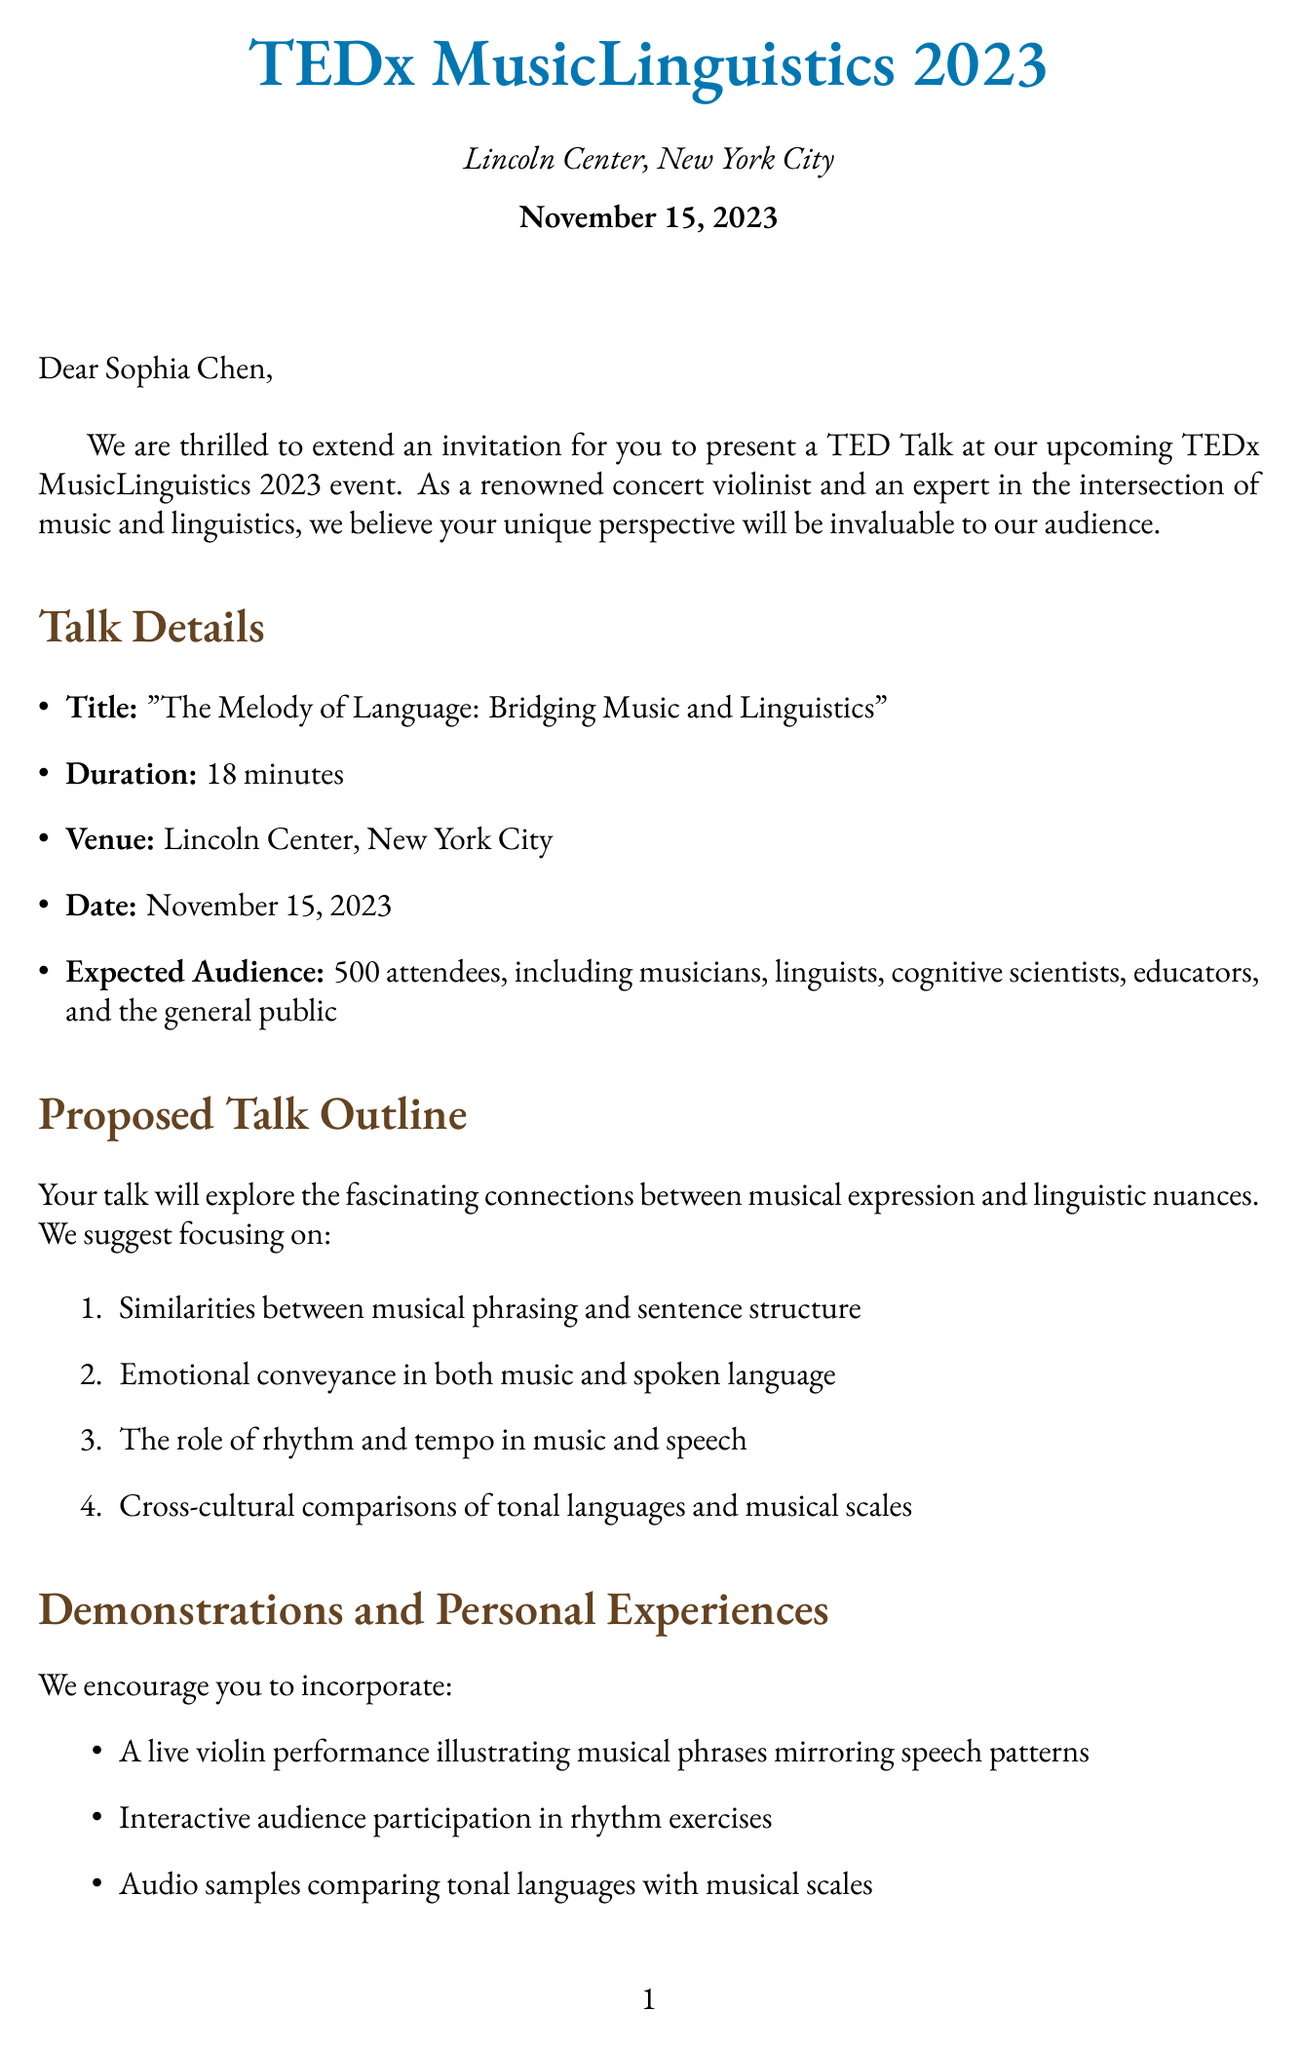What is the name of the speaker? The document states the speaker's name as Sophia Chen.
Answer: Sophia Chen What is the date of the TED Talk? The letter mentions the date of the TED Talk as November 15, 2023.
Answer: November 15, 2023 What is the duration of the talk? The document specifies that the duration of the talk is 18 minutes.
Answer: 18 minutes What is the title of the talk? The title of the talk is given as "The Melody of Language: Bridging Music and Linguistics."
Answer: The Melody of Language: Bridging Music and Linguistics Which orchestra did the speaker perform with? The personal anecdote mentions that the speaker performed with the London Symphony Orchestra.
Answer: London Symphony Orchestra How many attendees are expected at the event? The letter indicates that there will be 500 attendees expected at the event.
Answer: 500 Who is the author of the relevant research published in 2020? The document states that Dr. Isabelle Peretz is the author of the relevant research published in 2020.
Answer: Dr. Isabelle Peretz What opportunities are offered after the talk? The post-talk opportunities include a book signing, a panel discussion, and a podcast interview.
Answer: Book signing, panel discussion, podcast interview What type of audience is expected at the event? The expected audience includes musicians, linguists, cognitive scientists, educators, and the general public.
Answer: Musicians, linguists, cognitive scientists, educators, general public 